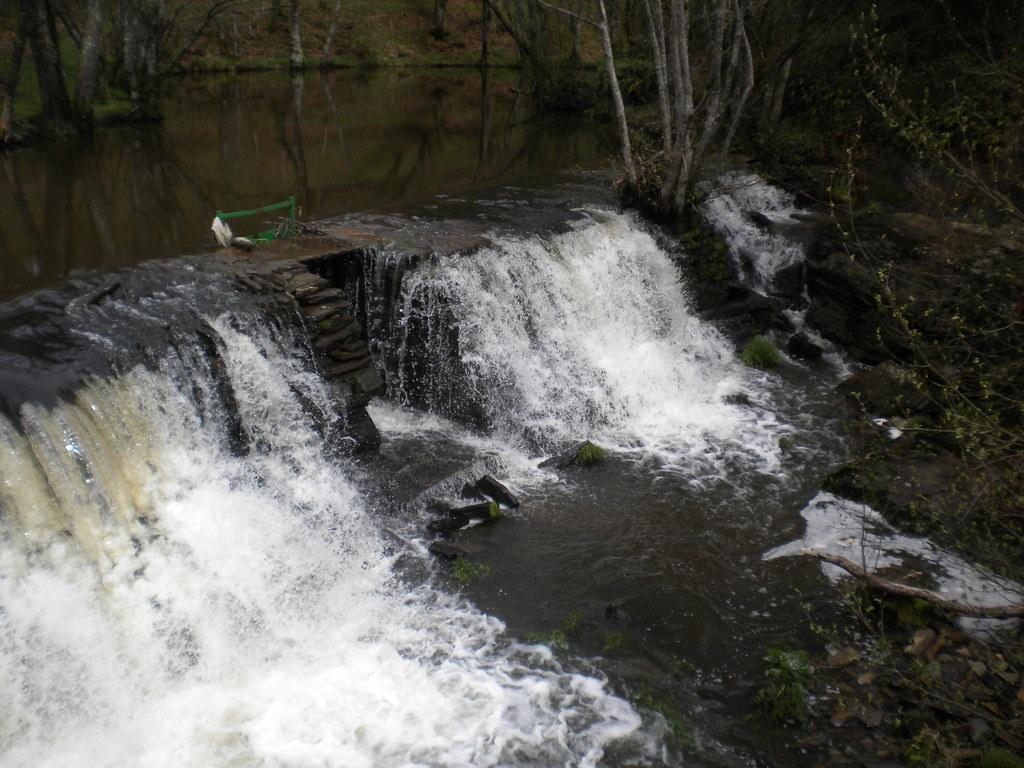What natural feature is the main subject of the image? There is a waterfall in the image. What type of vegetation can be seen in the background of the image? There are trees in the background of the image. What is present at the bottom of the image? There are stones at the bottom of the image. What type of disease is affecting the waterfall in the image? There is no indication of any disease affecting the waterfall in the image. What type of weather can be seen in the image? The image does not provide enough information to determine the weather conditions. 